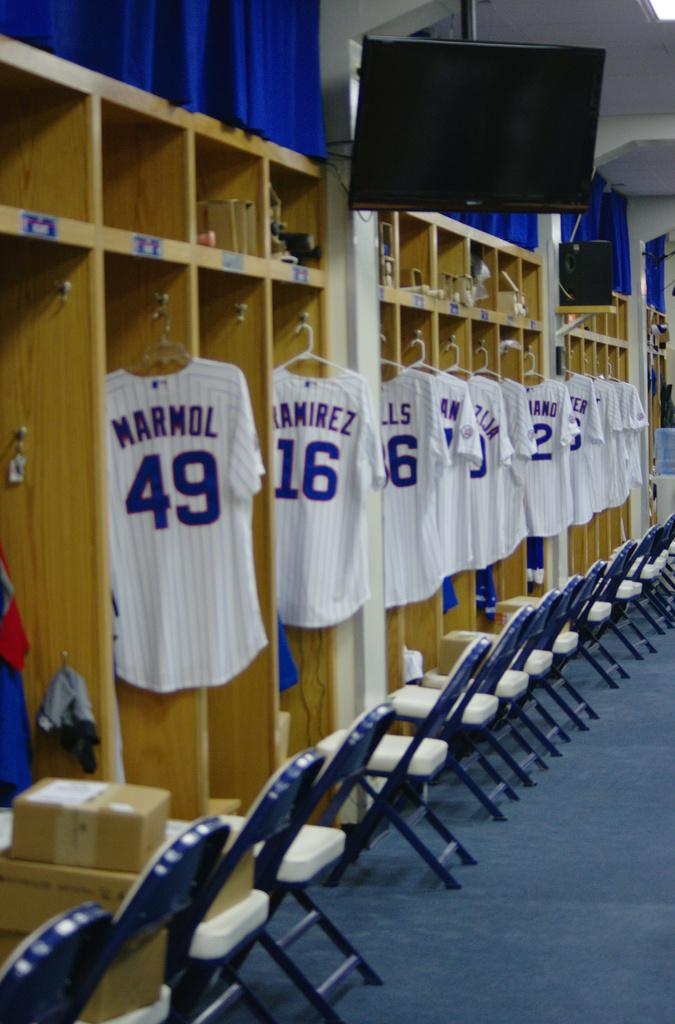<image>
Write a terse but informative summary of the picture. A whole lot of jerseys hanging in their lockers with Marmol and Ramirez in front.i 